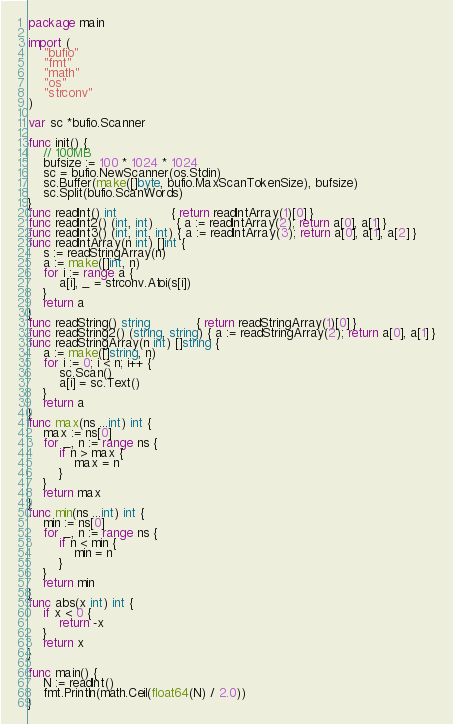<code> <loc_0><loc_0><loc_500><loc_500><_Go_>package main

import (
	"bufio"
	"fmt"
	"math"
	"os"
	"strconv"
)

var sc *bufio.Scanner

func init() {
	// 100MB
	bufsize := 100 * 1024 * 1024
	sc = bufio.NewScanner(os.Stdin)
	sc.Buffer(make([]byte, bufio.MaxScanTokenSize), bufsize)
	sc.Split(bufio.ScanWords)
}
func readInt() int              { return readIntArray(1)[0] }
func readInt2() (int, int)      { a := readIntArray(2); return a[0], a[1] }
func readInt3() (int, int, int) { a := readIntArray(3); return a[0], a[1], a[2] }
func readIntArray(n int) []int {
	s := readStringArray(n)
	a := make([]int, n)
	for i := range a {
		a[i], _ = strconv.Atoi(s[i])
	}
	return a
}
func readString() string            { return readStringArray(1)[0] }
func readString2() (string, string) { a := readStringArray(2); return a[0], a[1] }
func readStringArray(n int) []string {
	a := make([]string, n)
	for i := 0; i < n; i++ {
		sc.Scan()
		a[i] = sc.Text()
	}
	return a
}
func max(ns ...int) int {
	max := ns[0]
	for _, n := range ns {
		if n > max {
			max = n
		}
	}
	return max
}
func min(ns ...int) int {
	min := ns[0]
	for _, n := range ns {
		if n < min {
			min = n
		}
	}
	return min
}
func abs(x int) int {
	if x < 0 {
		return -x
	}
	return x
}

func main() {
	N := readInt()
	fmt.Println(math.Ceil(float64(N) / 2.0))
}
</code> 